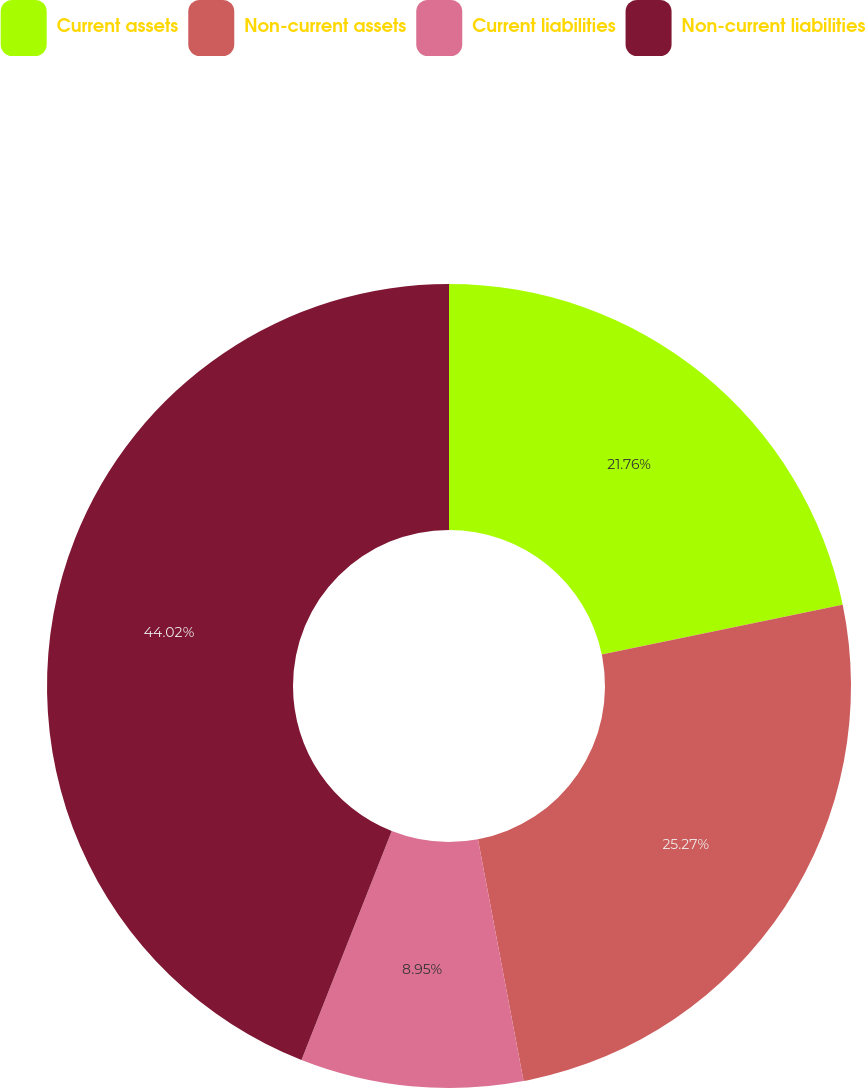Convert chart to OTSL. <chart><loc_0><loc_0><loc_500><loc_500><pie_chart><fcel>Current assets<fcel>Non-current assets<fcel>Current liabilities<fcel>Non-current liabilities<nl><fcel>21.76%<fcel>25.27%<fcel>8.95%<fcel>44.02%<nl></chart> 